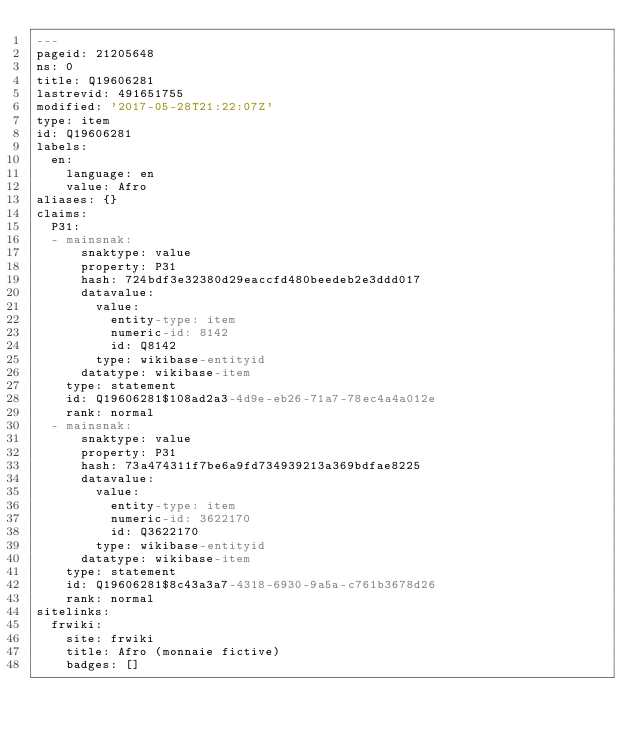<code> <loc_0><loc_0><loc_500><loc_500><_YAML_>---
pageid: 21205648
ns: 0
title: Q19606281
lastrevid: 491651755
modified: '2017-05-28T21:22:07Z'
type: item
id: Q19606281
labels:
  en:
    language: en
    value: Afro
aliases: {}
claims:
  P31:
  - mainsnak:
      snaktype: value
      property: P31
      hash: 724bdf3e32380d29eaccfd480beedeb2e3ddd017
      datavalue:
        value:
          entity-type: item
          numeric-id: 8142
          id: Q8142
        type: wikibase-entityid
      datatype: wikibase-item
    type: statement
    id: Q19606281$108ad2a3-4d9e-eb26-71a7-78ec4a4a012e
    rank: normal
  - mainsnak:
      snaktype: value
      property: P31
      hash: 73a474311f7be6a9fd734939213a369bdfae8225
      datavalue:
        value:
          entity-type: item
          numeric-id: 3622170
          id: Q3622170
        type: wikibase-entityid
      datatype: wikibase-item
    type: statement
    id: Q19606281$8c43a3a7-4318-6930-9a5a-c761b3678d26
    rank: normal
sitelinks:
  frwiki:
    site: frwiki
    title: Afro (monnaie fictive)
    badges: []
</code> 